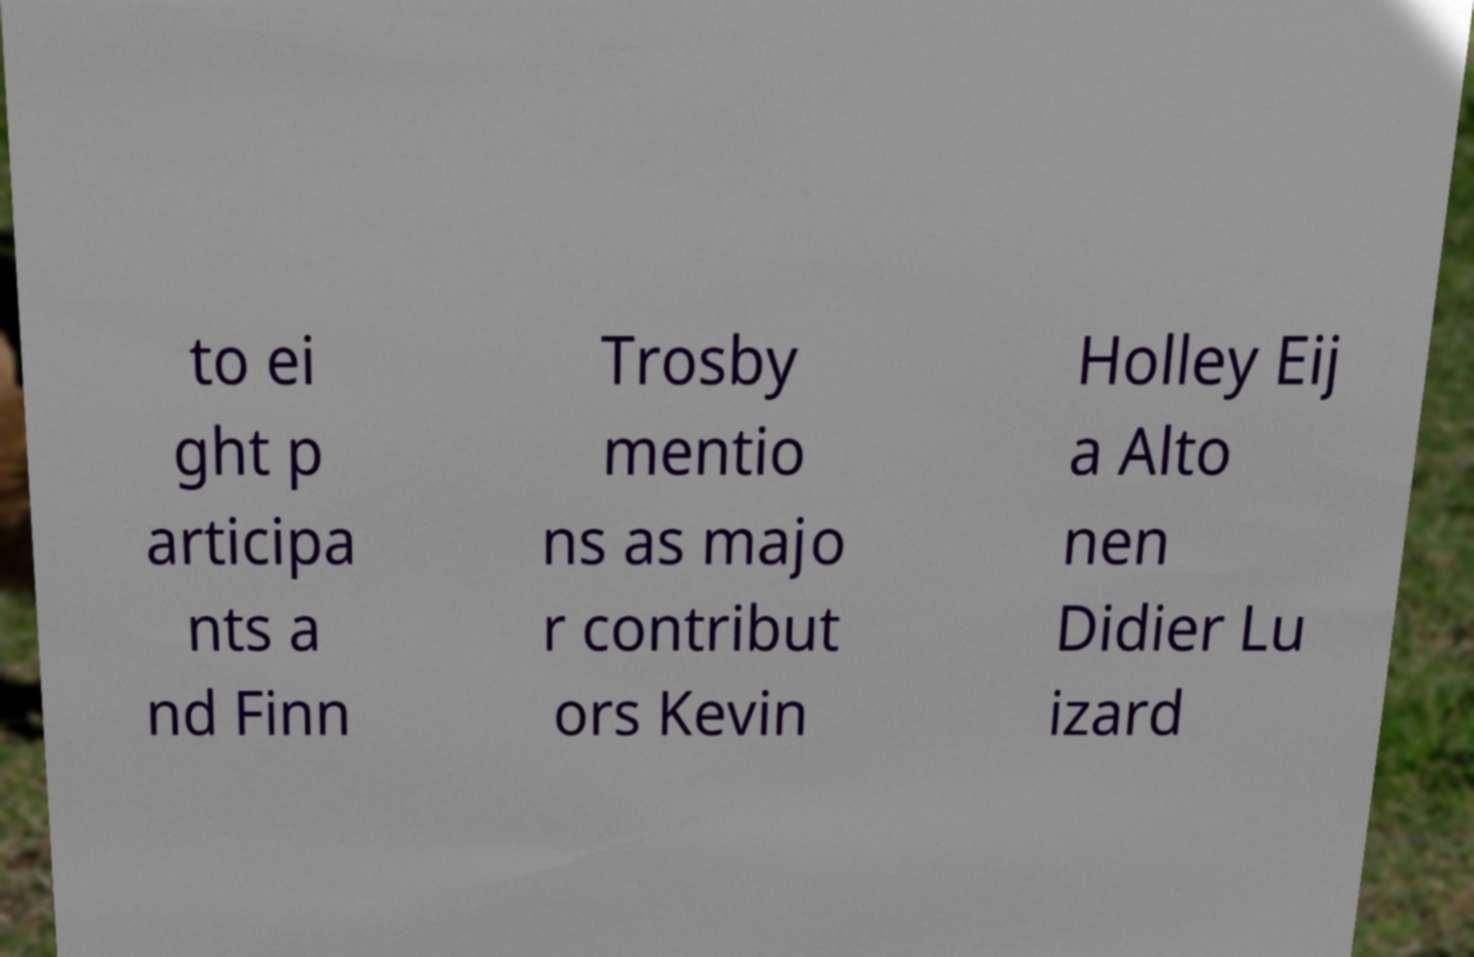Can you read and provide the text displayed in the image?This photo seems to have some interesting text. Can you extract and type it out for me? to ei ght p articipa nts a nd Finn Trosby mentio ns as majo r contribut ors Kevin Holley Eij a Alto nen Didier Lu izard 